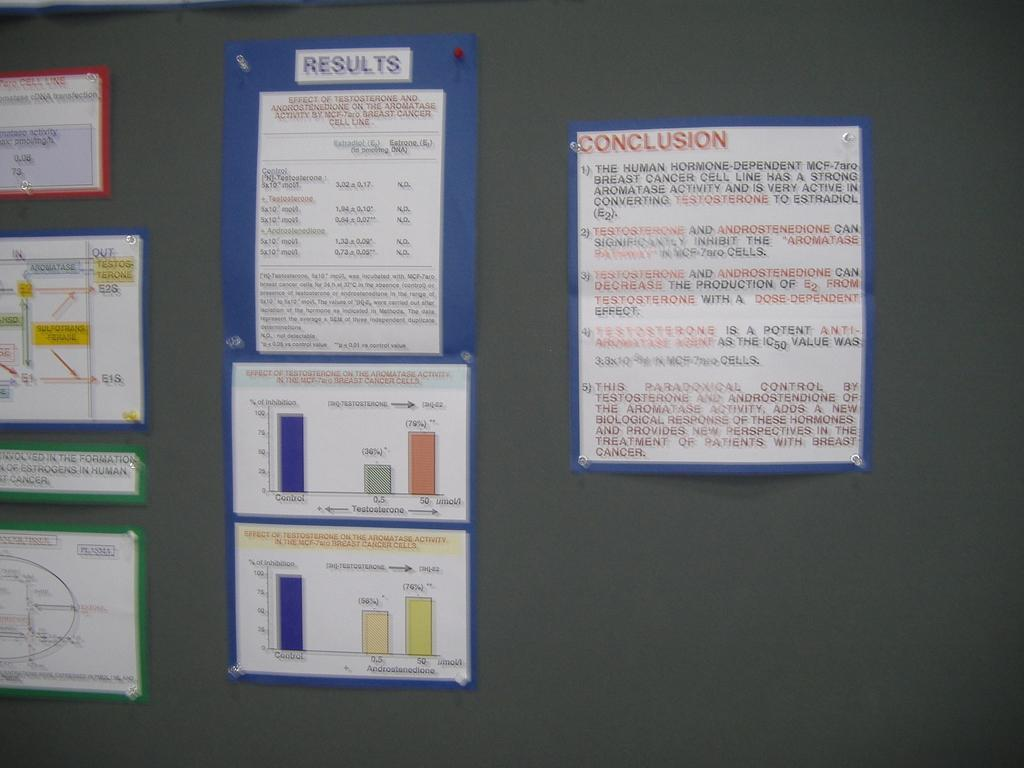<image>
Create a compact narrative representing the image presented. Several documents pinned to a wall with one reading conclusion on the top. 